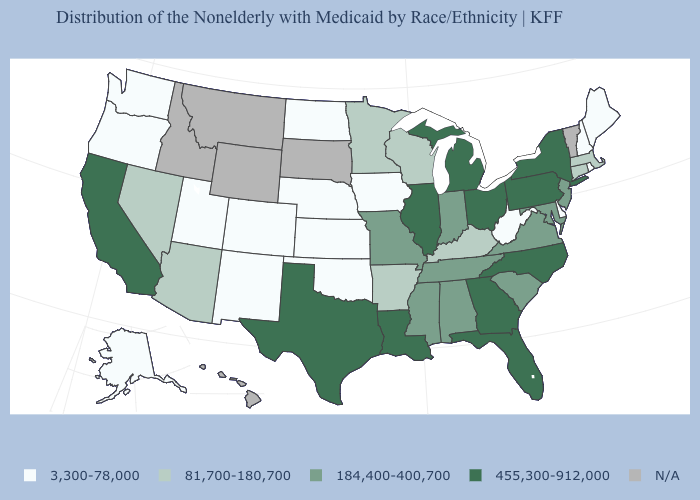How many symbols are there in the legend?
Quick response, please. 5. Which states have the lowest value in the USA?
Answer briefly. Alaska, Colorado, Delaware, Iowa, Kansas, Maine, Nebraska, New Hampshire, New Mexico, North Dakota, Oklahoma, Oregon, Rhode Island, Utah, Washington, West Virginia. Among the states that border Pennsylvania , does Delaware have the lowest value?
Be succinct. Yes. Does Pennsylvania have the highest value in the USA?
Concise answer only. Yes. What is the highest value in the USA?
Concise answer only. 455,300-912,000. How many symbols are there in the legend?
Quick response, please. 5. Does Louisiana have the highest value in the South?
Concise answer only. Yes. Among the states that border Georgia , does Florida have the lowest value?
Short answer required. No. What is the lowest value in states that border Nevada?
Concise answer only. 3,300-78,000. What is the value of Ohio?
Give a very brief answer. 455,300-912,000. Does Maine have the lowest value in the Northeast?
Answer briefly. Yes. What is the lowest value in states that border Utah?
Quick response, please. 3,300-78,000. What is the highest value in the USA?
Keep it brief. 455,300-912,000. What is the lowest value in the MidWest?
Write a very short answer. 3,300-78,000. 